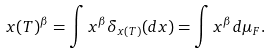<formula> <loc_0><loc_0><loc_500><loc_500>x ( T ) ^ { \beta } = \int x ^ { \beta } \delta _ { x ( T ) } ( d x ) = \int x ^ { \beta } d \mu _ { F } .</formula> 